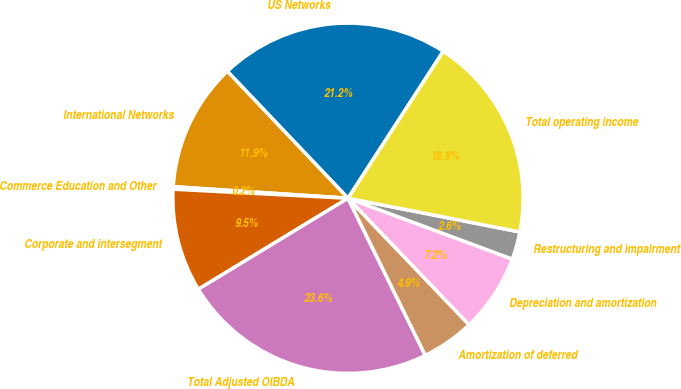Convert chart to OTSL. <chart><loc_0><loc_0><loc_500><loc_500><pie_chart><fcel>US Networks<fcel>International Networks<fcel>Commerce Education and Other<fcel>Corporate and intersegment<fcel>Total Adjusted OIBDA<fcel>Amortization of deferred<fcel>Depreciation and amortization<fcel>Restructuring and impairment<fcel>Total operating income<nl><fcel>21.25%<fcel>11.85%<fcel>0.23%<fcel>9.52%<fcel>23.58%<fcel>4.88%<fcel>7.2%<fcel>2.56%<fcel>18.93%<nl></chart> 